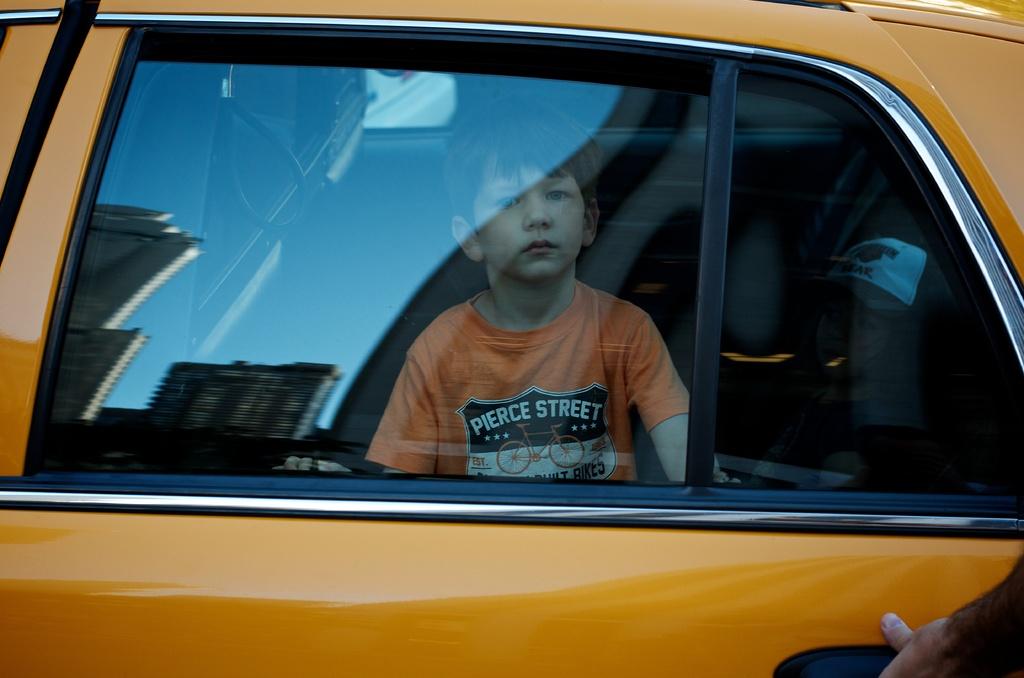What does the logo on the boy's shirt say?
Make the answer very short. Pierce street. Is pierce street on the boy's shirt a bicycle company?
Give a very brief answer. Yes. 